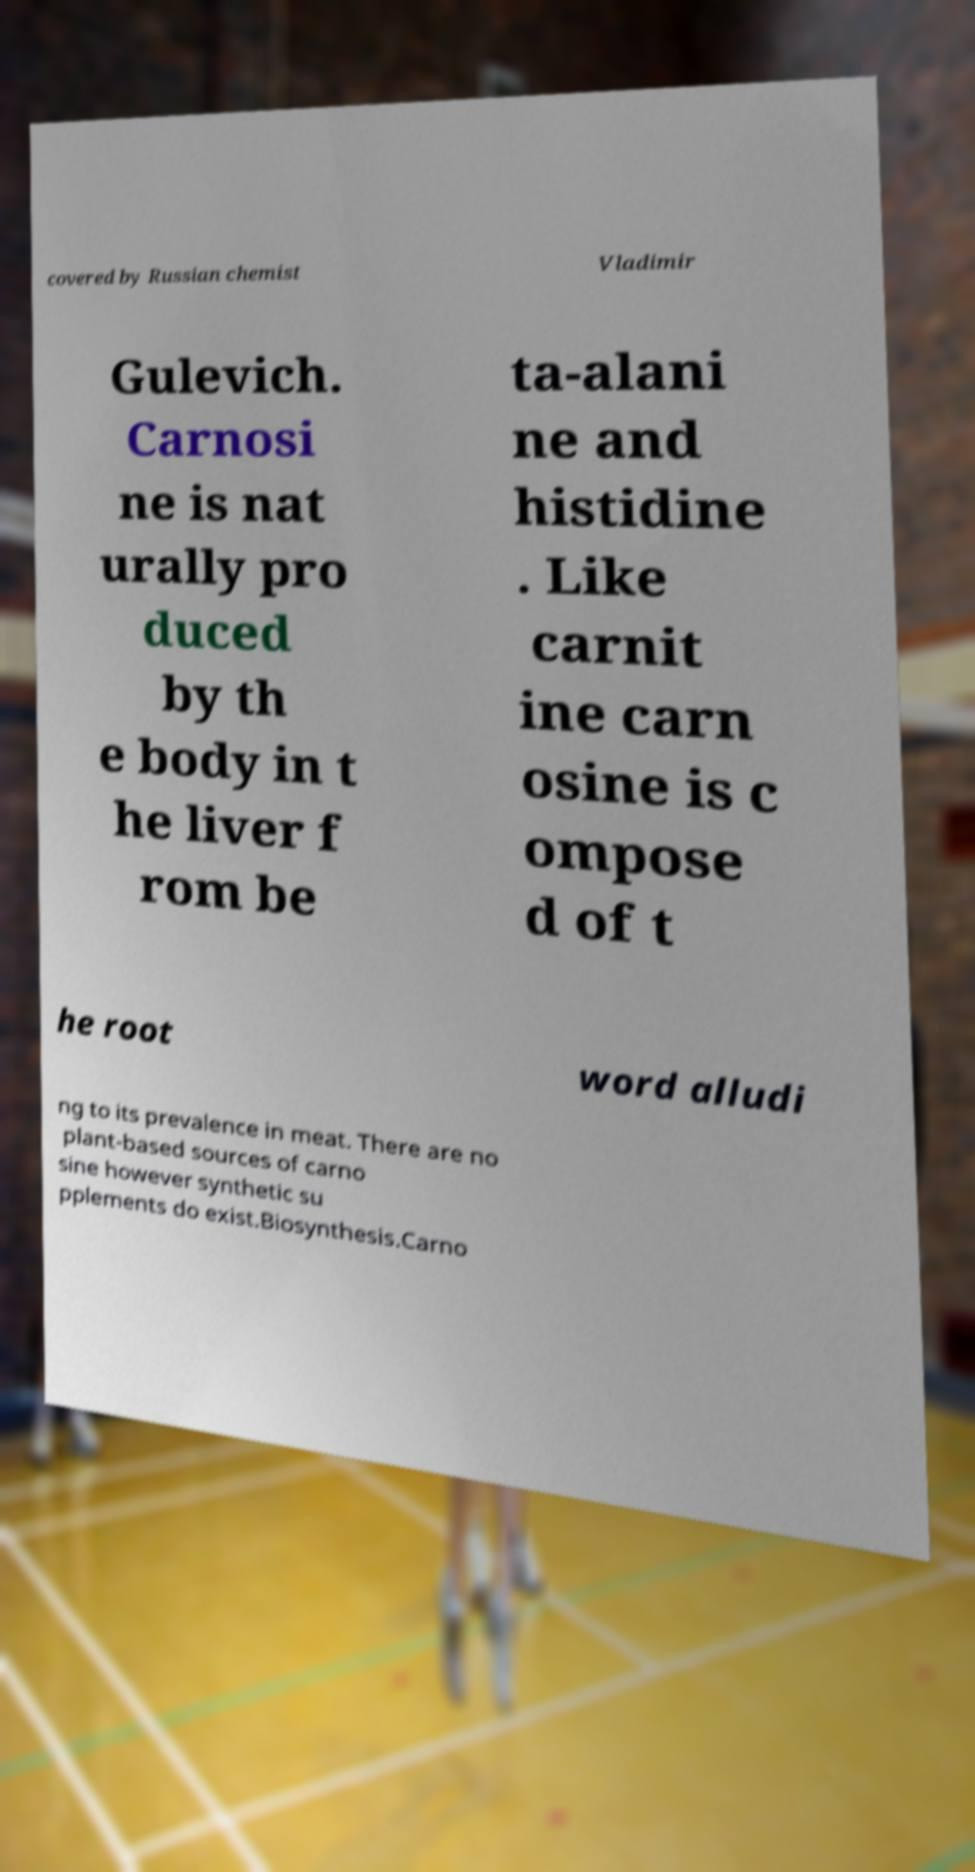Can you accurately transcribe the text from the provided image for me? covered by Russian chemist Vladimir Gulevich. Carnosi ne is nat urally pro duced by th e body in t he liver f rom be ta-alani ne and histidine . Like carnit ine carn osine is c ompose d of t he root word alludi ng to its prevalence in meat. There are no plant-based sources of carno sine however synthetic su pplements do exist.Biosynthesis.Carno 